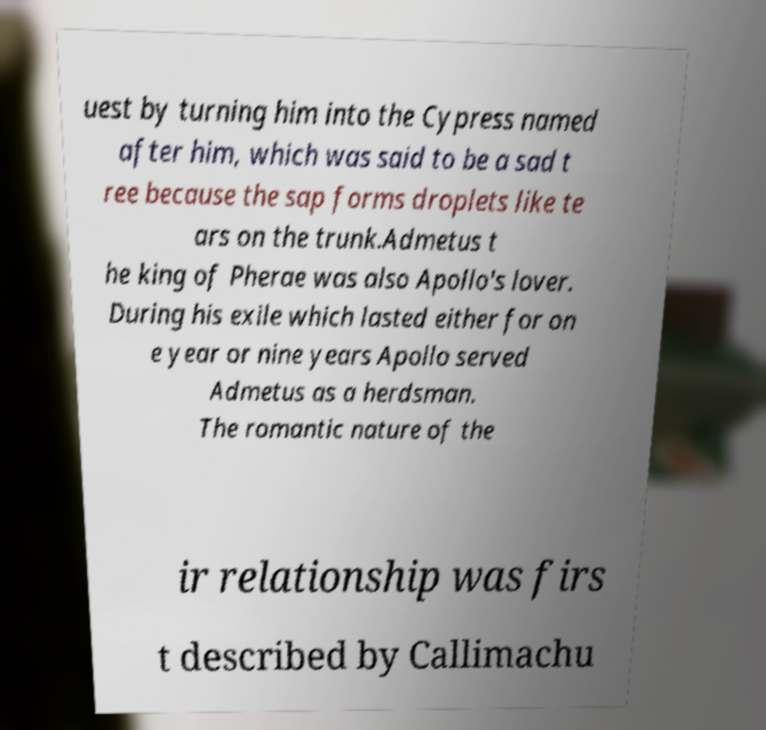Can you accurately transcribe the text from the provided image for me? uest by turning him into the Cypress named after him, which was said to be a sad t ree because the sap forms droplets like te ars on the trunk.Admetus t he king of Pherae was also Apollo's lover. During his exile which lasted either for on e year or nine years Apollo served Admetus as a herdsman. The romantic nature of the ir relationship was firs t described by Callimachu 